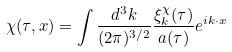Convert formula to latex. <formula><loc_0><loc_0><loc_500><loc_500>\chi ( \tau , { x } ) = \int \frac { d ^ { 3 } k } { ( 2 \pi ) ^ { 3 / 2 } } \frac { \xi ^ { \chi } _ { k } ( \tau ) } { a ( \tau ) } e ^ { i { k } \cdot { x } }</formula> 